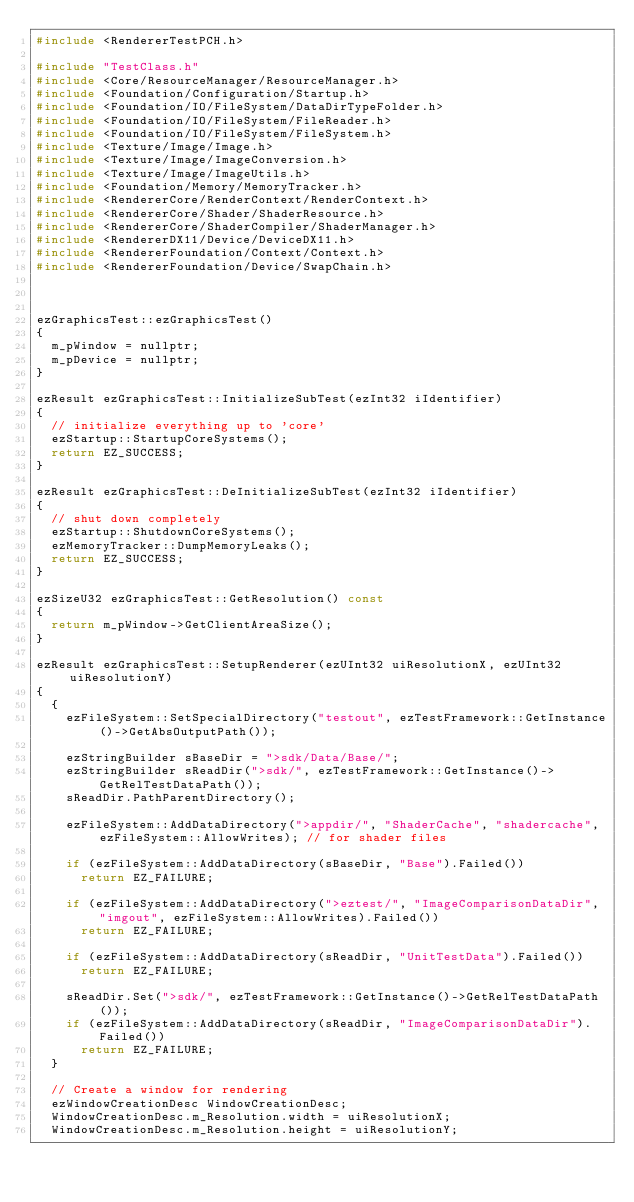Convert code to text. <code><loc_0><loc_0><loc_500><loc_500><_C++_>#include <RendererTestPCH.h>

#include "TestClass.h"
#include <Core/ResourceManager/ResourceManager.h>
#include <Foundation/Configuration/Startup.h>
#include <Foundation/IO/FileSystem/DataDirTypeFolder.h>
#include <Foundation/IO/FileSystem/FileReader.h>
#include <Foundation/IO/FileSystem/FileSystem.h>
#include <Texture/Image/Image.h>
#include <Texture/Image/ImageConversion.h>
#include <Texture/Image/ImageUtils.h>
#include <Foundation/Memory/MemoryTracker.h>
#include <RendererCore/RenderContext/RenderContext.h>
#include <RendererCore/Shader/ShaderResource.h>
#include <RendererCore/ShaderCompiler/ShaderManager.h>
#include <RendererDX11/Device/DeviceDX11.h>
#include <RendererFoundation/Context/Context.h>
#include <RendererFoundation/Device/SwapChain.h>



ezGraphicsTest::ezGraphicsTest()
{
  m_pWindow = nullptr;
  m_pDevice = nullptr;
}

ezResult ezGraphicsTest::InitializeSubTest(ezInt32 iIdentifier)
{
  // initialize everything up to 'core'
  ezStartup::StartupCoreSystems();
  return EZ_SUCCESS;
}

ezResult ezGraphicsTest::DeInitializeSubTest(ezInt32 iIdentifier)
{
  // shut down completely
  ezStartup::ShutdownCoreSystems();
  ezMemoryTracker::DumpMemoryLeaks();
  return EZ_SUCCESS;
}

ezSizeU32 ezGraphicsTest::GetResolution() const
{
  return m_pWindow->GetClientAreaSize();
}

ezResult ezGraphicsTest::SetupRenderer(ezUInt32 uiResolutionX, ezUInt32 uiResolutionY)
{
  {
    ezFileSystem::SetSpecialDirectory("testout", ezTestFramework::GetInstance()->GetAbsOutputPath());

    ezStringBuilder sBaseDir = ">sdk/Data/Base/";
    ezStringBuilder sReadDir(">sdk/", ezTestFramework::GetInstance()->GetRelTestDataPath());
    sReadDir.PathParentDirectory();

    ezFileSystem::AddDataDirectory(">appdir/", "ShaderCache", "shadercache", ezFileSystem::AllowWrites); // for shader files

    if (ezFileSystem::AddDataDirectory(sBaseDir, "Base").Failed())
      return EZ_FAILURE;

    if (ezFileSystem::AddDataDirectory(">eztest/", "ImageComparisonDataDir", "imgout", ezFileSystem::AllowWrites).Failed())
      return EZ_FAILURE;

    if (ezFileSystem::AddDataDirectory(sReadDir, "UnitTestData").Failed())
      return EZ_FAILURE;

    sReadDir.Set(">sdk/", ezTestFramework::GetInstance()->GetRelTestDataPath());
    if (ezFileSystem::AddDataDirectory(sReadDir, "ImageComparisonDataDir").Failed())
      return EZ_FAILURE;
  }

  // Create a window for rendering
  ezWindowCreationDesc WindowCreationDesc;
  WindowCreationDesc.m_Resolution.width = uiResolutionX;
  WindowCreationDesc.m_Resolution.height = uiResolutionY;</code> 